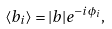Convert formula to latex. <formula><loc_0><loc_0><loc_500><loc_500>\langle b _ { i } \rangle = | b | e ^ { - i \phi _ { i } } ,</formula> 